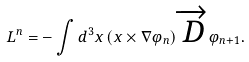<formula> <loc_0><loc_0><loc_500><loc_500>L ^ { n } = - \int d ^ { 3 } x \left ( x \times \nabla \varphi _ { n } \right ) \overrightarrow { D } \varphi _ { n + 1 } .</formula> 